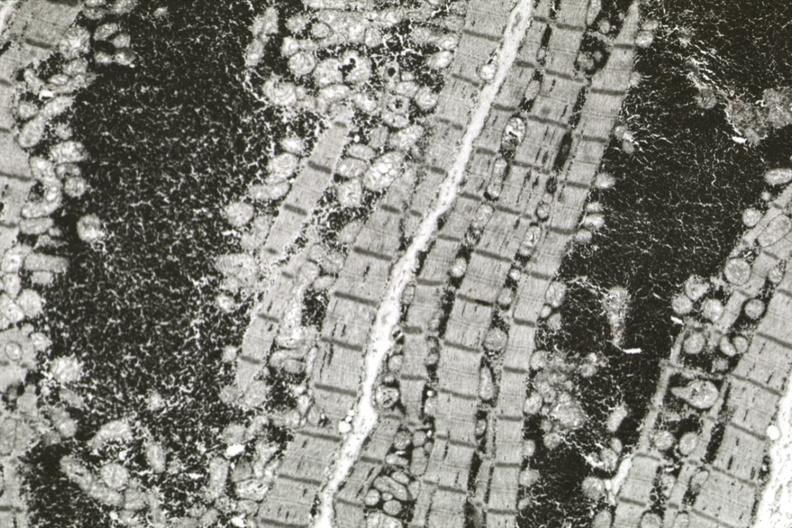what does this image show?
Answer the question using a single word or phrase. Excessive number mitochondria especially about nucleus early atrophy 